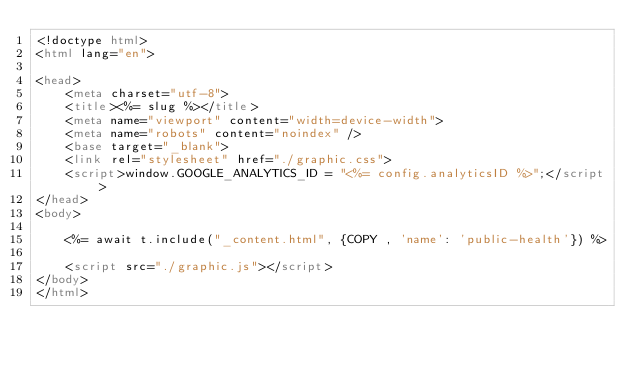<code> <loc_0><loc_0><loc_500><loc_500><_HTML_><!doctype html>
<html lang="en">

<head>
    <meta charset="utf-8">
    <title><%= slug %></title>
    <meta name="viewport" content="width=device-width">
    <meta name="robots" content="noindex" />
    <base target="_blank">
    <link rel="stylesheet" href="./graphic.css">
    <script>window.GOOGLE_ANALYTICS_ID = "<%= config.analyticsID %>";</script>
</head>
<body>

    <%= await t.include("_content.html", {COPY , 'name': 'public-health'}) %>

    <script src="./graphic.js"></script>
</body>
</html>
</code> 